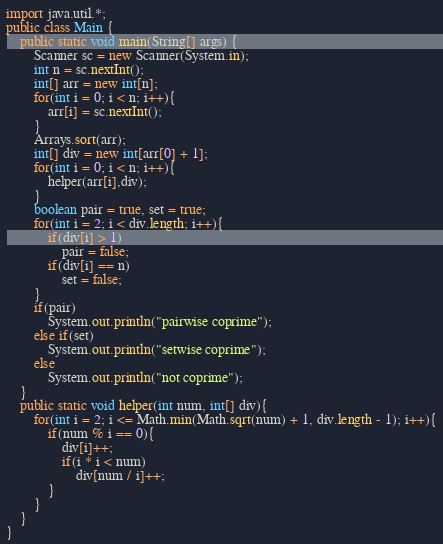Convert code to text. <code><loc_0><loc_0><loc_500><loc_500><_Java_>import java.util.*;
public class Main {
    public static void main(String[] args) {
        Scanner sc = new Scanner(System.in);
        int n = sc.nextInt();
        int[] arr = new int[n];
        for(int i = 0; i < n; i++){
            arr[i] = sc.nextInt();
        }
        Arrays.sort(arr);
        int[] div = new int[arr[0] + 1];
        for(int i = 0; i < n; i++){
            helper(arr[i],div);
        }
        boolean pair = true, set = true;
        for(int i = 2; i < div.length; i++){
            if(div[i] > 1)
                pair = false;
            if(div[i] == n)
                set = false;
        }
        if(pair)
            System.out.println("pairwise coprime");
        else if(set)
            System.out.println("setwise coprime");
        else
            System.out.println("not coprime");
    }
    public static void helper(int num, int[] div){
        for(int i = 2; i <= Math.min(Math.sqrt(num) + 1, div.length - 1); i++){
            if(num % i == 0){
                div[i]++;
                if(i * i < num)
                    div[num / i]++;
            }
        }
    }
}</code> 